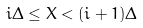<formula> <loc_0><loc_0><loc_500><loc_500>i \Delta \leq X < ( i + 1 ) \Delta</formula> 